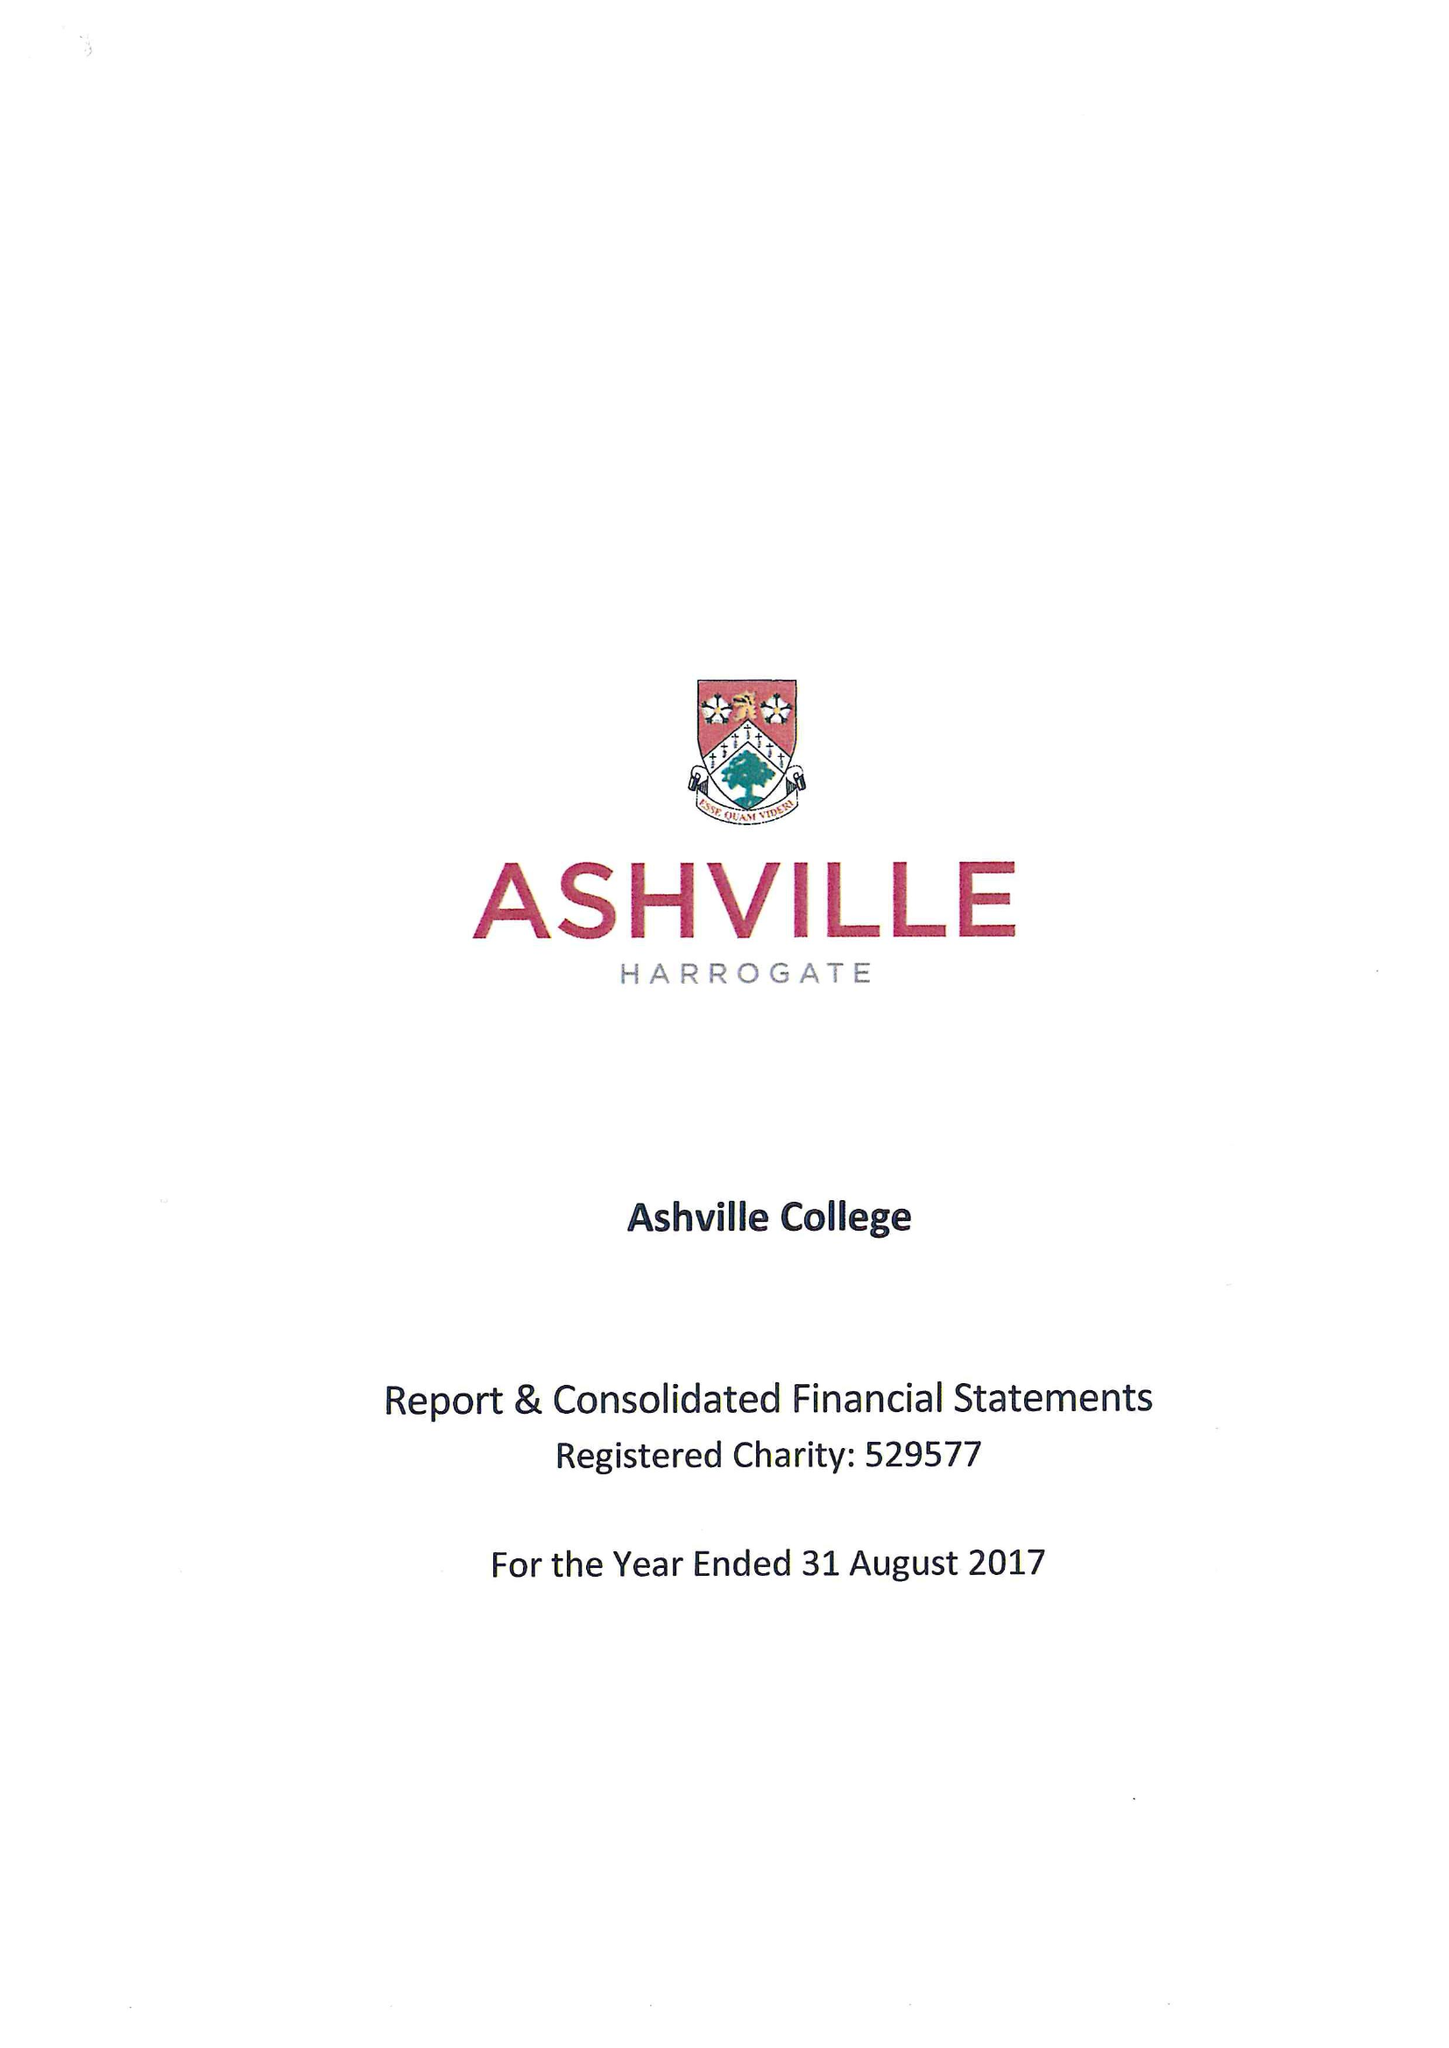What is the value for the charity_name?
Answer the question using a single word or phrase. Ashville College 